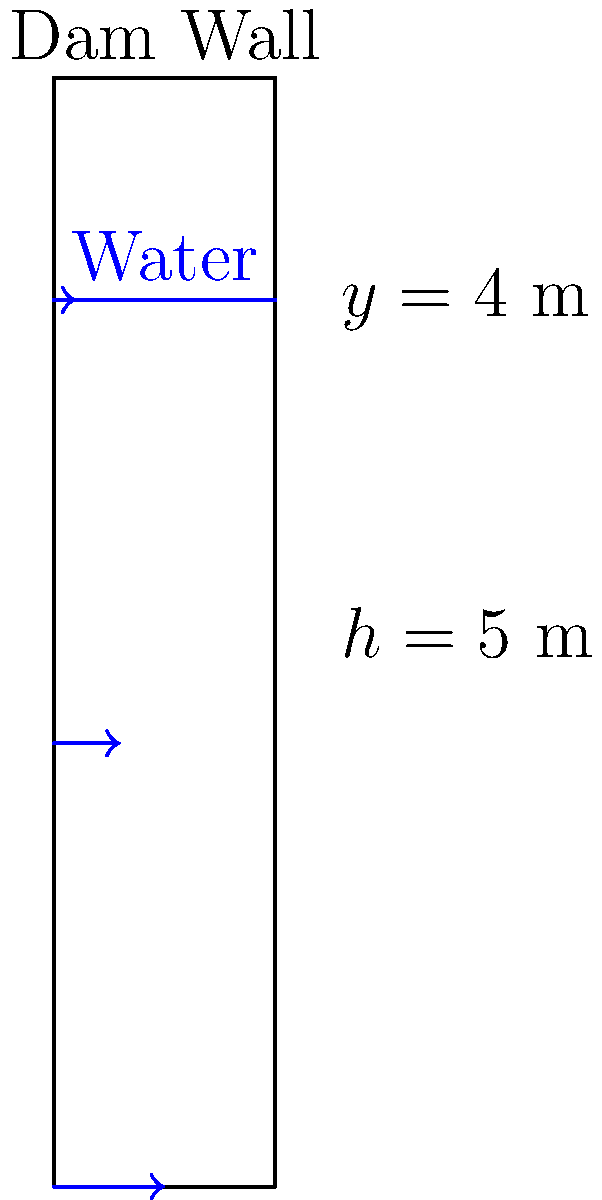A rectangular dam wall has a height of 5 meters, and the water level is currently at 4 meters. Calculate the water pressure (in kPa) at the base of the dam wall. Assume the density of water is 1000 kg/m³ and the acceleration due to gravity is 9.81 m/s². Let's approach this step-by-step:

1) The formula for hydrostatic pressure is:
   $$P = \rho g h$$
   Where:
   $P$ = pressure
   $\rho$ (rho) = density of water
   $g$ = acceleration due to gravity
   $h$ = height of water column above the point of measurement

2) We're given:
   $\rho = 1000$ kg/m³
   $g = 9.81$ m/s²
   $h = 4$ m (the water level)

3) Let's substitute these values into the formula:
   $$P = 1000 \times 9.81 \times 4$$

4) Calculate:
   $$P = 39,240 \text{ N/m²}$$

5) Convert N/m² to kPa:
   $$P = 39.24 \text{ kPa}$$

Therefore, the water pressure at the base of the dam wall is 39.24 kPa.
Answer: 39.24 kPa 